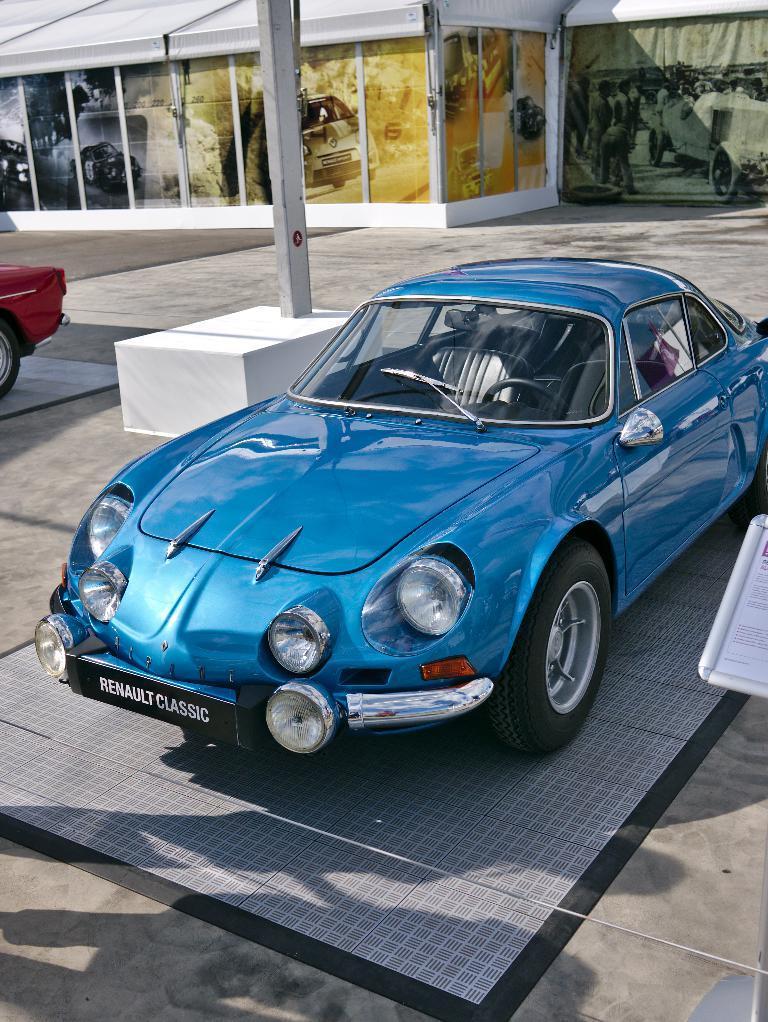Please provide a concise description of this image. In this image in the foreground there is blue car and on the left there is a red car. 